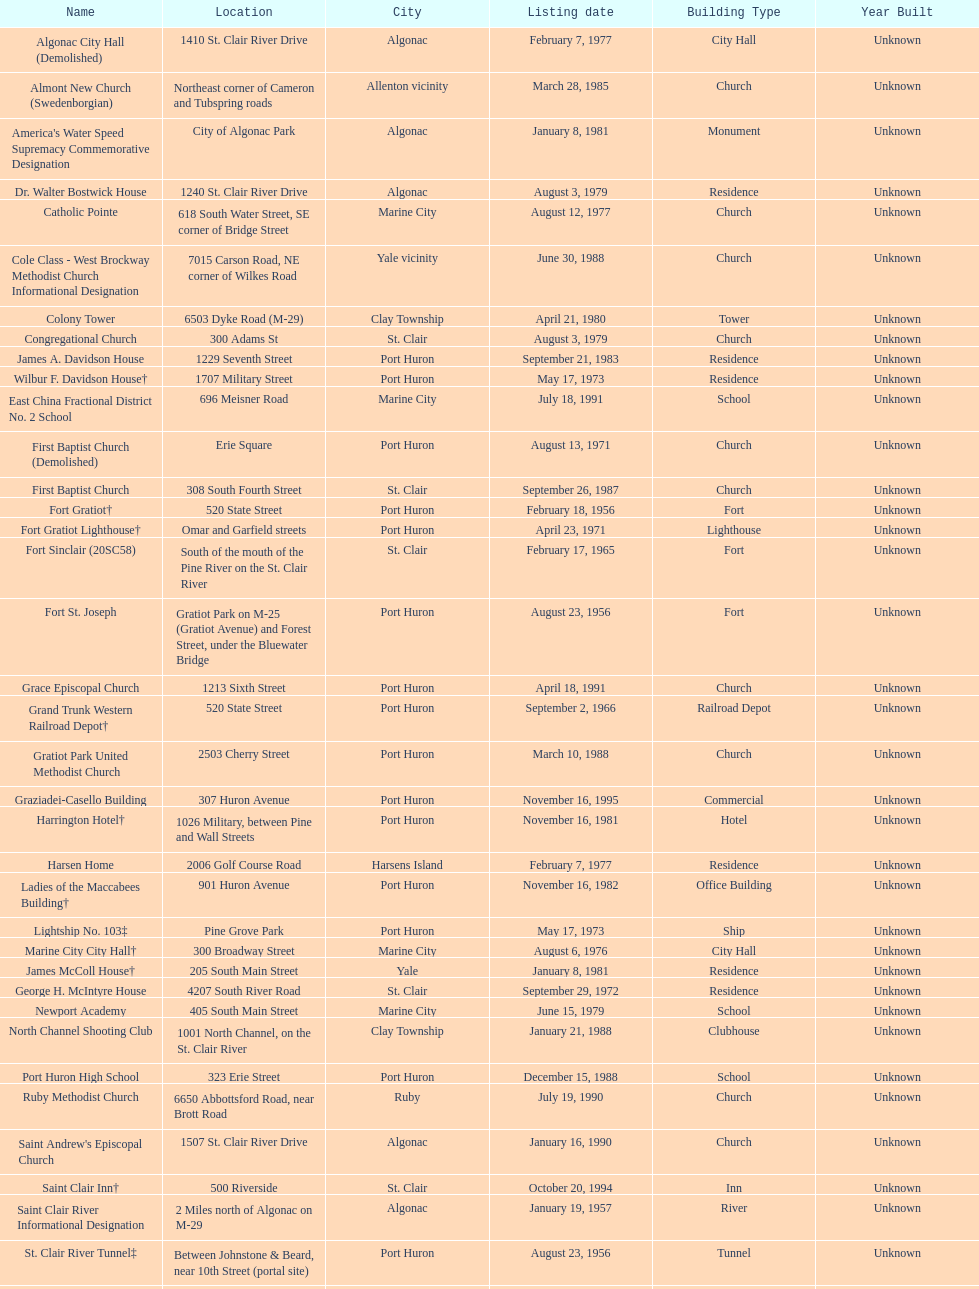What is the total number of locations in the city of algonac? 5. 